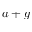<formula> <loc_0><loc_0><loc_500><loc_500>a + g</formula> 